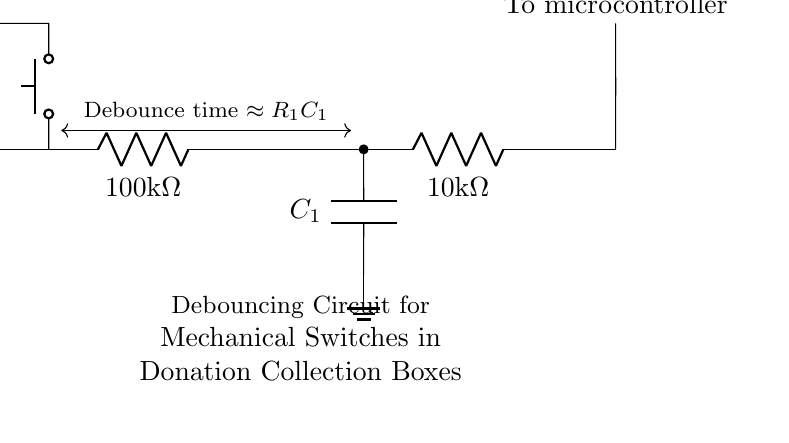What is the resistance value of R1? R1 is labeled as 100 kilo-ohms, which is the resistance specified in the circuit.
Answer: 100 kilo-ohms What is the capacitance value of C1? C1 is a capacitor, but its capacitance value is not specified in the circuit diagram, so it does not have an explicit value mentioned.
Answer: Not specified What happens at the output of the circuit? The output leads to a microcontroller; thus, when the switch is pressed, it debounces the signal before sending it to the microcontroller.
Answer: To microcontroller What is the purpose of R2 in this circuit? R2, being a second resistor, helps in creating a voltage divider with R1; however, its specific role in debouncing isn't explicitly detailed in the circuit itself.
Answer: Voltage divider What is the formula for the debounce time in this circuit? The diagram indicates that the debounce time can be approximated by the product of R1 and C1, represented as R1C1.
Answer: R1C1 What type of switches are being debounced in this circuit? The visual indicates the use of a push button for mechanical switches, which typically have bounce that needs to be eliminated for clean signal input.
Answer: Push button What is the general function of the capacitor in this circuit? The capacitor in a debouncing circuit allows smoothing of the voltage signal, preventing rapid changes that occur during mechanical bouncing of the switch contacts.
Answer: Smoothing the voltage signal 